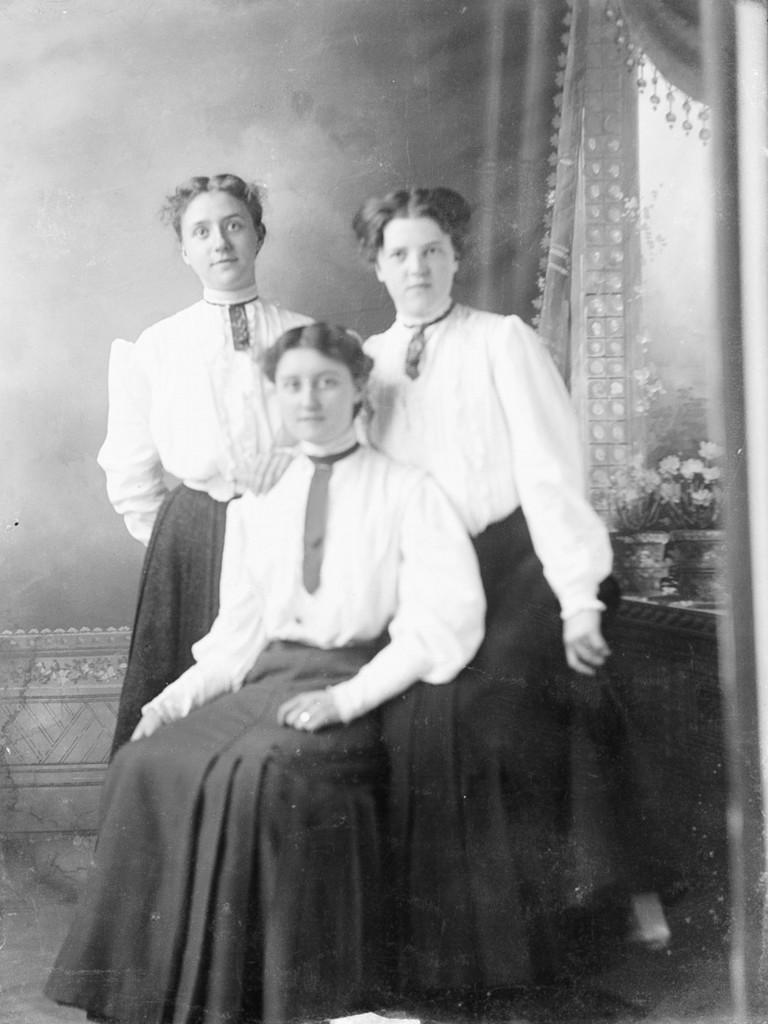How would you summarize this image in a sentence or two? In this image I can see three persons. In front the person is sitting, background I can see few flower pots and I can see few curtains and the image is black and white. 